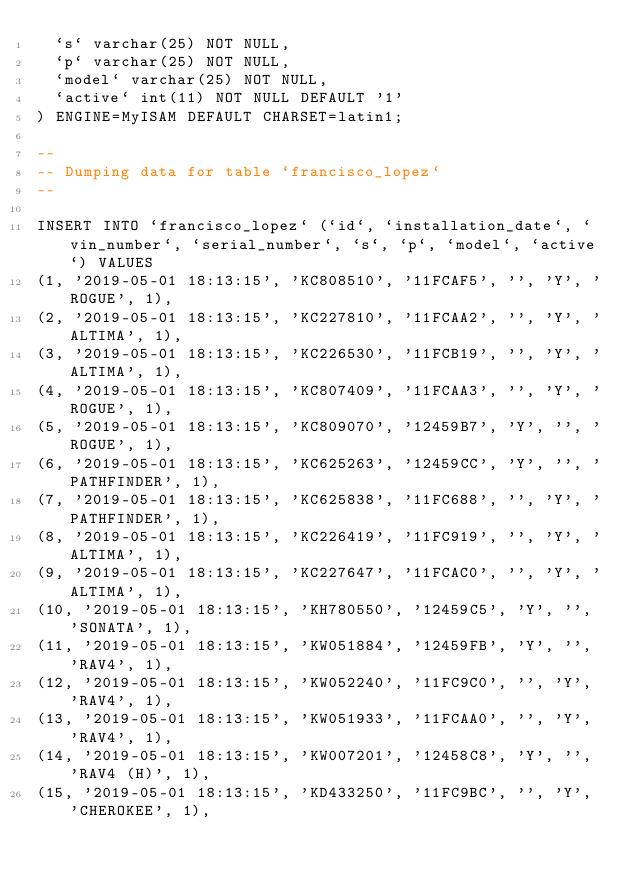<code> <loc_0><loc_0><loc_500><loc_500><_SQL_>  `s` varchar(25) NOT NULL,
  `p` varchar(25) NOT NULL,
  `model` varchar(25) NOT NULL,
  `active` int(11) NOT NULL DEFAULT '1'
) ENGINE=MyISAM DEFAULT CHARSET=latin1;

--
-- Dumping data for table `francisco_lopez`
--

INSERT INTO `francisco_lopez` (`id`, `installation_date`, `vin_number`, `serial_number`, `s`, `p`, `model`, `active`) VALUES
(1, '2019-05-01 18:13:15', 'KC808510', '11FCAF5', '', 'Y', 'ROGUE', 1),
(2, '2019-05-01 18:13:15', 'KC227810', '11FCAA2', '', 'Y', 'ALTIMA', 1),
(3, '2019-05-01 18:13:15', 'KC226530', '11FCB19', '', 'Y', 'ALTIMA', 1),
(4, '2019-05-01 18:13:15', 'KC807409', '11FCAA3', '', 'Y', 'ROGUE', 1),
(5, '2019-05-01 18:13:15', 'KC809070', '12459B7', 'Y', '', 'ROGUE', 1),
(6, '2019-05-01 18:13:15', 'KC625263', '12459CC', 'Y', '', 'PATHFINDER', 1),
(7, '2019-05-01 18:13:15', 'KC625838', '11FC688', '', 'Y', 'PATHFINDER', 1),
(8, '2019-05-01 18:13:15', 'KC226419', '11FC919', '', 'Y', 'ALTIMA', 1),
(9, '2019-05-01 18:13:15', 'KC227647', '11FCAC0', '', 'Y', 'ALTIMA', 1),
(10, '2019-05-01 18:13:15', 'KH780550', '12459C5', 'Y', '', 'SONATA', 1),
(11, '2019-05-01 18:13:15', 'KW051884', '12459FB', 'Y', '', 'RAV4', 1),
(12, '2019-05-01 18:13:15', 'KW052240', '11FC9C0', '', 'Y', 'RAV4', 1),
(13, '2019-05-01 18:13:15', 'KW051933', '11FCAA0', '', 'Y', 'RAV4', 1),
(14, '2019-05-01 18:13:15', 'KW007201', '12458C8', 'Y', '', 'RAV4 (H)', 1),
(15, '2019-05-01 18:13:15', 'KD433250', '11FC9BC', '', 'Y', 'CHEROKEE', 1),</code> 